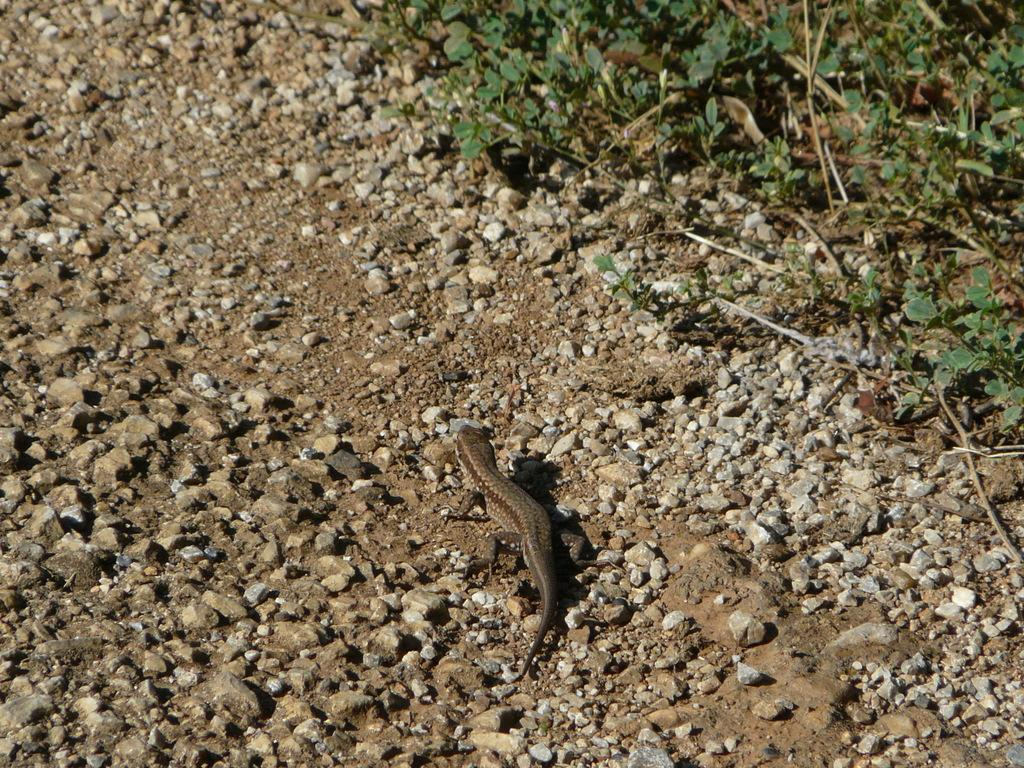What type of animal is present in the image? There is an animal in the image, but its specific type cannot be determined from the provided facts. Can you describe the position of the animal in the image? The animal is on the ground in the image. What can be seen in the background of the image? There are plants visible in the background of the image. Is the animal a part of a spy team in the image? There is no indication in the image that the animal is a part of a spy team or any team for that matter. 